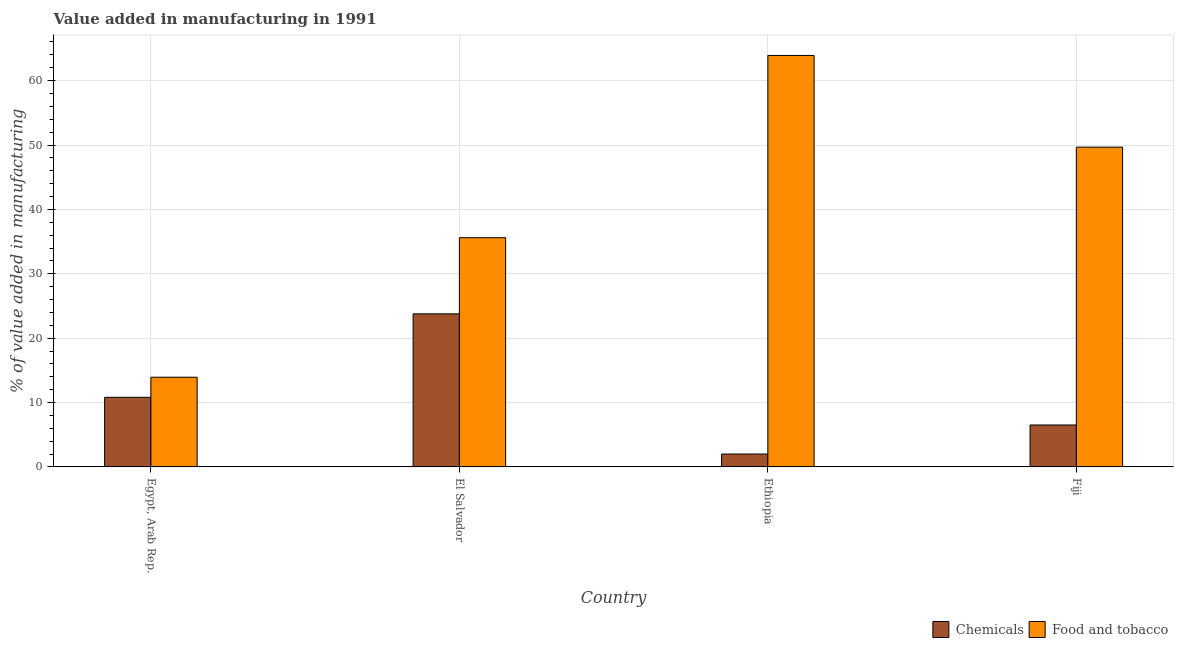How many groups of bars are there?
Offer a terse response. 4. Are the number of bars on each tick of the X-axis equal?
Offer a very short reply. Yes. What is the label of the 2nd group of bars from the left?
Ensure brevity in your answer.  El Salvador. In how many cases, is the number of bars for a given country not equal to the number of legend labels?
Make the answer very short. 0. What is the value added by manufacturing food and tobacco in Ethiopia?
Provide a succinct answer. 63.91. Across all countries, what is the maximum value added by  manufacturing chemicals?
Offer a terse response. 23.78. Across all countries, what is the minimum value added by  manufacturing chemicals?
Your answer should be very brief. 2. In which country was the value added by  manufacturing chemicals maximum?
Provide a short and direct response. El Salvador. In which country was the value added by  manufacturing chemicals minimum?
Your answer should be compact. Ethiopia. What is the total value added by  manufacturing chemicals in the graph?
Give a very brief answer. 43.11. What is the difference between the value added by manufacturing food and tobacco in Ethiopia and that in Fiji?
Your answer should be compact. 14.24. What is the difference between the value added by manufacturing food and tobacco in Fiji and the value added by  manufacturing chemicals in El Salvador?
Offer a very short reply. 25.89. What is the average value added by  manufacturing chemicals per country?
Provide a succinct answer. 10.78. What is the difference between the value added by manufacturing food and tobacco and value added by  manufacturing chemicals in El Salvador?
Make the answer very short. 11.83. In how many countries, is the value added by manufacturing food and tobacco greater than 56 %?
Keep it short and to the point. 1. What is the ratio of the value added by manufacturing food and tobacco in Egypt, Arab Rep. to that in Ethiopia?
Your answer should be compact. 0.22. Is the value added by  manufacturing chemicals in El Salvador less than that in Ethiopia?
Give a very brief answer. No. What is the difference between the highest and the second highest value added by manufacturing food and tobacco?
Your response must be concise. 14.24. What is the difference between the highest and the lowest value added by  manufacturing chemicals?
Offer a very short reply. 21.77. Is the sum of the value added by  manufacturing chemicals in Egypt, Arab Rep. and El Salvador greater than the maximum value added by manufacturing food and tobacco across all countries?
Your response must be concise. No. What does the 2nd bar from the left in Egypt, Arab Rep. represents?
Your answer should be compact. Food and tobacco. What does the 1st bar from the right in Ethiopia represents?
Offer a terse response. Food and tobacco. How many bars are there?
Offer a terse response. 8. Are all the bars in the graph horizontal?
Offer a terse response. No. What is the difference between two consecutive major ticks on the Y-axis?
Offer a very short reply. 10. Are the values on the major ticks of Y-axis written in scientific E-notation?
Offer a terse response. No. Where does the legend appear in the graph?
Provide a short and direct response. Bottom right. How many legend labels are there?
Your answer should be compact. 2. What is the title of the graph?
Make the answer very short. Value added in manufacturing in 1991. Does "Savings" appear as one of the legend labels in the graph?
Ensure brevity in your answer.  No. What is the label or title of the X-axis?
Your answer should be compact. Country. What is the label or title of the Y-axis?
Give a very brief answer. % of value added in manufacturing. What is the % of value added in manufacturing of Chemicals in Egypt, Arab Rep.?
Provide a short and direct response. 10.81. What is the % of value added in manufacturing of Food and tobacco in Egypt, Arab Rep.?
Provide a short and direct response. 13.93. What is the % of value added in manufacturing of Chemicals in El Salvador?
Ensure brevity in your answer.  23.78. What is the % of value added in manufacturing in Food and tobacco in El Salvador?
Make the answer very short. 35.6. What is the % of value added in manufacturing of Chemicals in Ethiopia?
Ensure brevity in your answer.  2. What is the % of value added in manufacturing of Food and tobacco in Ethiopia?
Provide a short and direct response. 63.91. What is the % of value added in manufacturing in Chemicals in Fiji?
Your response must be concise. 6.51. What is the % of value added in manufacturing of Food and tobacco in Fiji?
Your answer should be compact. 49.67. Across all countries, what is the maximum % of value added in manufacturing of Chemicals?
Provide a succinct answer. 23.78. Across all countries, what is the maximum % of value added in manufacturing in Food and tobacco?
Give a very brief answer. 63.91. Across all countries, what is the minimum % of value added in manufacturing of Chemicals?
Your answer should be compact. 2. Across all countries, what is the minimum % of value added in manufacturing of Food and tobacco?
Provide a succinct answer. 13.93. What is the total % of value added in manufacturing of Chemicals in the graph?
Your response must be concise. 43.11. What is the total % of value added in manufacturing in Food and tobacco in the graph?
Your response must be concise. 163.11. What is the difference between the % of value added in manufacturing of Chemicals in Egypt, Arab Rep. and that in El Salvador?
Ensure brevity in your answer.  -12.96. What is the difference between the % of value added in manufacturing of Food and tobacco in Egypt, Arab Rep. and that in El Salvador?
Provide a succinct answer. -21.67. What is the difference between the % of value added in manufacturing in Chemicals in Egypt, Arab Rep. and that in Ethiopia?
Make the answer very short. 8.81. What is the difference between the % of value added in manufacturing in Food and tobacco in Egypt, Arab Rep. and that in Ethiopia?
Ensure brevity in your answer.  -49.98. What is the difference between the % of value added in manufacturing in Chemicals in Egypt, Arab Rep. and that in Fiji?
Ensure brevity in your answer.  4.3. What is the difference between the % of value added in manufacturing in Food and tobacco in Egypt, Arab Rep. and that in Fiji?
Provide a succinct answer. -35.73. What is the difference between the % of value added in manufacturing in Chemicals in El Salvador and that in Ethiopia?
Your answer should be compact. 21.77. What is the difference between the % of value added in manufacturing of Food and tobacco in El Salvador and that in Ethiopia?
Your answer should be compact. -28.3. What is the difference between the % of value added in manufacturing in Chemicals in El Salvador and that in Fiji?
Offer a terse response. 17.26. What is the difference between the % of value added in manufacturing in Food and tobacco in El Salvador and that in Fiji?
Your answer should be compact. -14.06. What is the difference between the % of value added in manufacturing in Chemicals in Ethiopia and that in Fiji?
Ensure brevity in your answer.  -4.51. What is the difference between the % of value added in manufacturing in Food and tobacco in Ethiopia and that in Fiji?
Your response must be concise. 14.24. What is the difference between the % of value added in manufacturing of Chemicals in Egypt, Arab Rep. and the % of value added in manufacturing of Food and tobacco in El Salvador?
Keep it short and to the point. -24.79. What is the difference between the % of value added in manufacturing in Chemicals in Egypt, Arab Rep. and the % of value added in manufacturing in Food and tobacco in Ethiopia?
Your answer should be very brief. -53.1. What is the difference between the % of value added in manufacturing in Chemicals in Egypt, Arab Rep. and the % of value added in manufacturing in Food and tobacco in Fiji?
Provide a succinct answer. -38.85. What is the difference between the % of value added in manufacturing of Chemicals in El Salvador and the % of value added in manufacturing of Food and tobacco in Ethiopia?
Ensure brevity in your answer.  -40.13. What is the difference between the % of value added in manufacturing in Chemicals in El Salvador and the % of value added in manufacturing in Food and tobacco in Fiji?
Give a very brief answer. -25.89. What is the difference between the % of value added in manufacturing of Chemicals in Ethiopia and the % of value added in manufacturing of Food and tobacco in Fiji?
Give a very brief answer. -47.66. What is the average % of value added in manufacturing in Chemicals per country?
Your response must be concise. 10.78. What is the average % of value added in manufacturing of Food and tobacco per country?
Your answer should be compact. 40.78. What is the difference between the % of value added in manufacturing of Chemicals and % of value added in manufacturing of Food and tobacco in Egypt, Arab Rep.?
Your answer should be very brief. -3.12. What is the difference between the % of value added in manufacturing in Chemicals and % of value added in manufacturing in Food and tobacco in El Salvador?
Your response must be concise. -11.83. What is the difference between the % of value added in manufacturing in Chemicals and % of value added in manufacturing in Food and tobacco in Ethiopia?
Ensure brevity in your answer.  -61.91. What is the difference between the % of value added in manufacturing in Chemicals and % of value added in manufacturing in Food and tobacco in Fiji?
Ensure brevity in your answer.  -43.15. What is the ratio of the % of value added in manufacturing in Chemicals in Egypt, Arab Rep. to that in El Salvador?
Make the answer very short. 0.45. What is the ratio of the % of value added in manufacturing of Food and tobacco in Egypt, Arab Rep. to that in El Salvador?
Your answer should be very brief. 0.39. What is the ratio of the % of value added in manufacturing of Chemicals in Egypt, Arab Rep. to that in Ethiopia?
Your response must be concise. 5.4. What is the ratio of the % of value added in manufacturing in Food and tobacco in Egypt, Arab Rep. to that in Ethiopia?
Your response must be concise. 0.22. What is the ratio of the % of value added in manufacturing of Chemicals in Egypt, Arab Rep. to that in Fiji?
Keep it short and to the point. 1.66. What is the ratio of the % of value added in manufacturing in Food and tobacco in Egypt, Arab Rep. to that in Fiji?
Your answer should be compact. 0.28. What is the ratio of the % of value added in manufacturing in Chemicals in El Salvador to that in Ethiopia?
Make the answer very short. 11.86. What is the ratio of the % of value added in manufacturing of Food and tobacco in El Salvador to that in Ethiopia?
Provide a short and direct response. 0.56. What is the ratio of the % of value added in manufacturing in Chemicals in El Salvador to that in Fiji?
Your answer should be compact. 3.65. What is the ratio of the % of value added in manufacturing in Food and tobacco in El Salvador to that in Fiji?
Offer a very short reply. 0.72. What is the ratio of the % of value added in manufacturing in Chemicals in Ethiopia to that in Fiji?
Your response must be concise. 0.31. What is the ratio of the % of value added in manufacturing in Food and tobacco in Ethiopia to that in Fiji?
Provide a short and direct response. 1.29. What is the difference between the highest and the second highest % of value added in manufacturing of Chemicals?
Offer a terse response. 12.96. What is the difference between the highest and the second highest % of value added in manufacturing in Food and tobacco?
Your response must be concise. 14.24. What is the difference between the highest and the lowest % of value added in manufacturing of Chemicals?
Your answer should be compact. 21.77. What is the difference between the highest and the lowest % of value added in manufacturing in Food and tobacco?
Give a very brief answer. 49.98. 